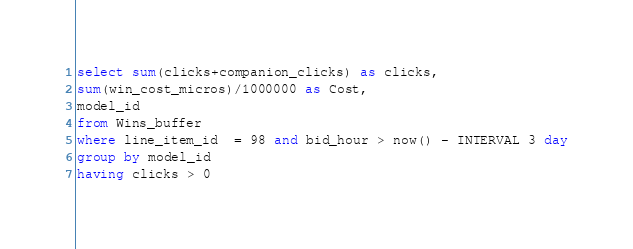<code> <loc_0><loc_0><loc_500><loc_500><_SQL_>select sum(clicks+companion_clicks) as clicks,
sum(win_cost_micros)/1000000 as Cost,
model_id 
from Wins_buffer 
where line_item_id  = 98 and bid_hour > now() - INTERVAL 3 day
group by model_id
having clicks > 0 

</code> 